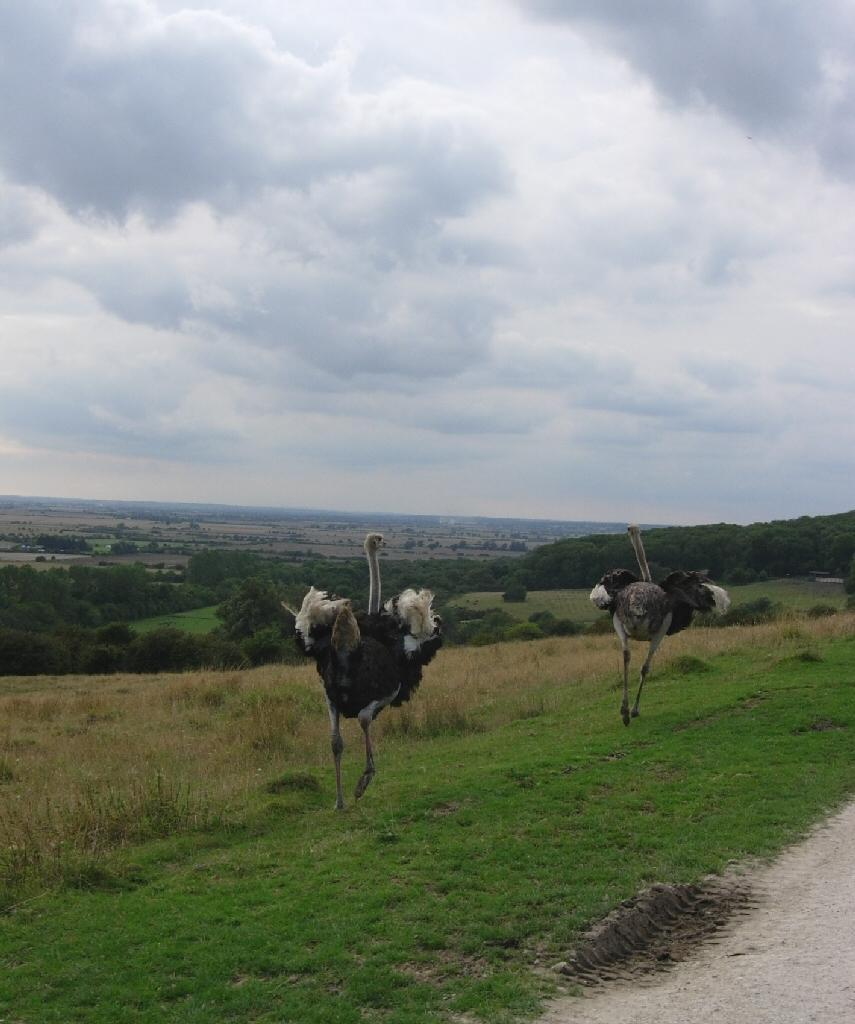Could you give a brief overview of what you see in this image? In this image we can see two birds which are walking and in the background of the image there are some trees and cloudy sky. 